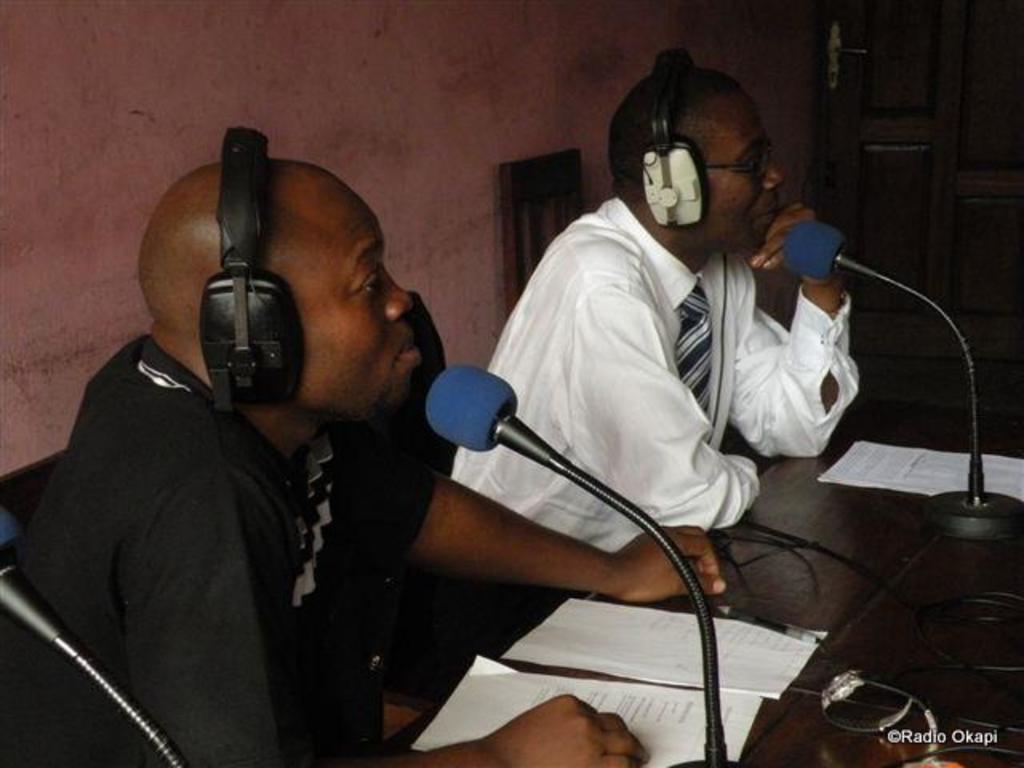How would you summarize this image in a sentence or two? This picture shows the inner view of a room. Two persons sitting on a chair near to the table and wearing headphones. There are some papers, some wires, one wooden door, three microphones attached to the table. 